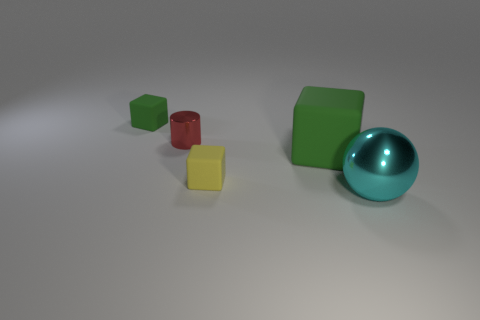What number of other things are there of the same color as the big sphere?
Offer a terse response. 0. Are there the same number of tiny green matte cubes in front of the small red metallic cylinder and tiny cyan rubber cubes?
Offer a very short reply. Yes. There is a shiny ball that is right of the rubber cube that is on the left side of the yellow matte object; how many small yellow cubes are left of it?
Offer a terse response. 1. There is a red cylinder; is it the same size as the green matte thing that is behind the small cylinder?
Offer a very short reply. Yes. How many small green rubber cubes are there?
Keep it short and to the point. 1. There is a metallic object that is behind the cyan sphere; is its size the same as the green object on the left side of the small yellow matte cube?
Give a very brief answer. Yes. What is the color of the other small matte object that is the same shape as the tiny green matte thing?
Keep it short and to the point. Yellow. Do the yellow thing and the small green object have the same shape?
Your response must be concise. Yes. There is another green thing that is the same shape as the large green object; what size is it?
Provide a short and direct response. Small. How many small objects are made of the same material as the ball?
Offer a terse response. 1. 